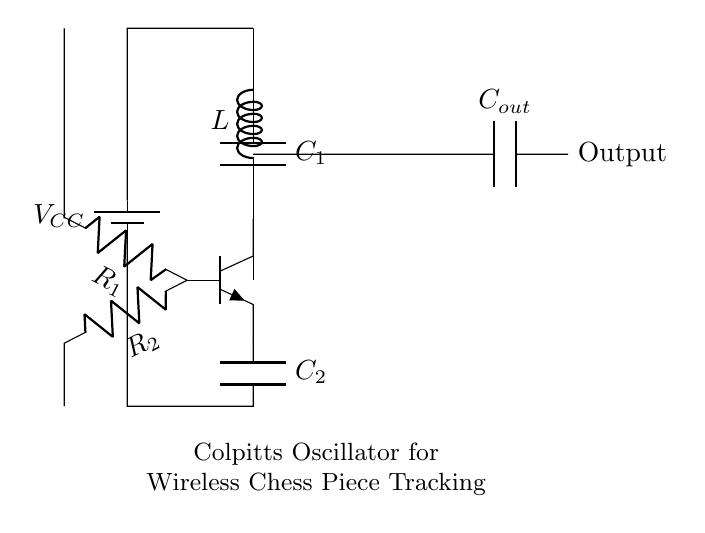What is the value of the main inductor in the circuit? The circuit shows an inductor labeled L, which does not have an explicit numerical value displayed. It likely represents a variable component, but based on the diagram, the value is not specified.
Answer: L What are the two capacitors in the circuit? The circuit includes capacitors labeled C1 and C2. They serve different roles in the oscillation process, with C1 participating in the main tank circuit and C2 connected to the emitter for feedback.
Answer: C1 and C2 What type of transistor is used in this Colpitts oscillator circuit? The diagram features a transistor labeled as npn, indicating it is an NPN bipolar junction transistor, which is common in oscillator applications.
Answer: npn What role does R1 play in the circuit? R1 is a resistor connected to the base of the transistor and is likely used to set the biasing conditions for the transistor, which is essential for transistor operation in oscillators.
Answer: Biasing How many resistors are present in the circuit? The circuit diagram contains two resistors, R1 and R2, which influence the feedback and gain of the oscillator circuit.
Answer: 2 What is the purpose of capacitor Cout in the circuit? Capacitor Cout is connected to the output and likely serves to filter the oscillation signal, allowing the desired frequency to pass while blocking unwanted frequencies.
Answer: Filtering What does VCC represent in this circuit? VCC is the supply voltage connected to the circuit, providing the necessary power for the transistor to operate and allowing it to function as an oscillator.
Answer: Supply voltage 